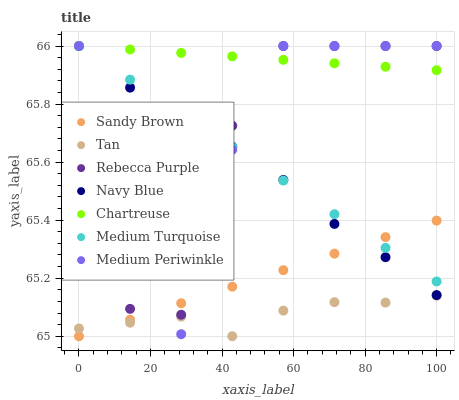Does Tan have the minimum area under the curve?
Answer yes or no. Yes. Does Chartreuse have the maximum area under the curve?
Answer yes or no. Yes. Does Medium Periwinkle have the minimum area under the curve?
Answer yes or no. No. Does Medium Periwinkle have the maximum area under the curve?
Answer yes or no. No. Is Sandy Brown the smoothest?
Answer yes or no. Yes. Is Rebecca Purple the roughest?
Answer yes or no. Yes. Is Medium Periwinkle the smoothest?
Answer yes or no. No. Is Medium Periwinkle the roughest?
Answer yes or no. No. Does Sandy Brown have the lowest value?
Answer yes or no. Yes. Does Medium Periwinkle have the lowest value?
Answer yes or no. No. Does Medium Turquoise have the highest value?
Answer yes or no. Yes. Does Tan have the highest value?
Answer yes or no. No. Is Sandy Brown less than Chartreuse?
Answer yes or no. Yes. Is Medium Turquoise greater than Tan?
Answer yes or no. Yes. Does Tan intersect Medium Periwinkle?
Answer yes or no. Yes. Is Tan less than Medium Periwinkle?
Answer yes or no. No. Is Tan greater than Medium Periwinkle?
Answer yes or no. No. Does Sandy Brown intersect Chartreuse?
Answer yes or no. No. 